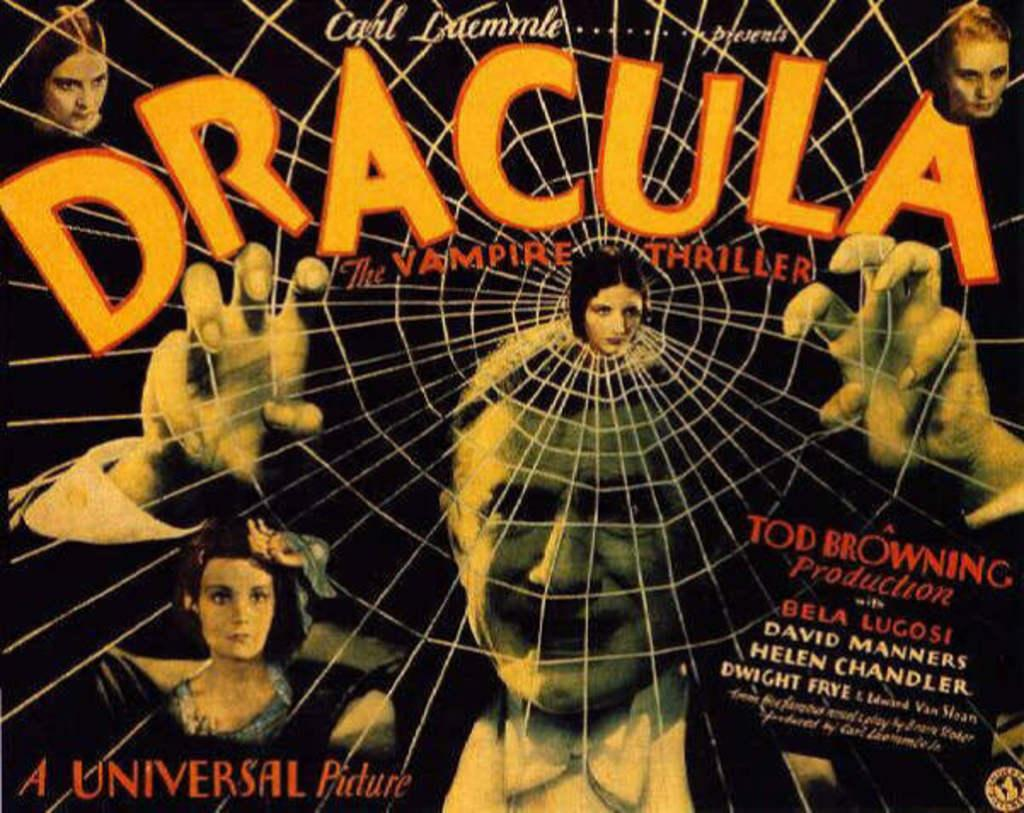<image>
Offer a succinct explanation of the picture presented. A poster showing Dracula with his hand lifted behind a spider web and other characters are shown around him. 